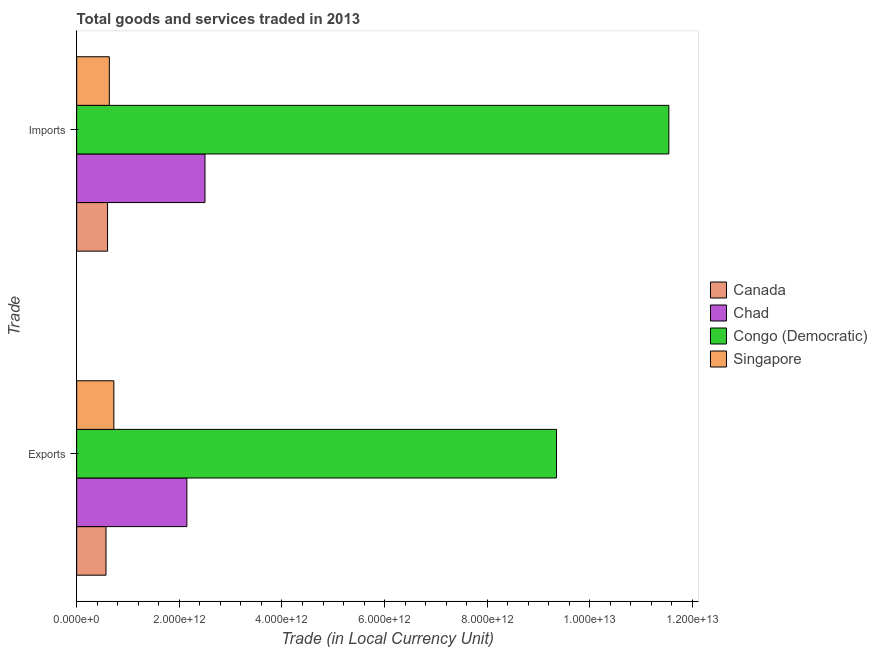How many groups of bars are there?
Offer a very short reply. 2. How many bars are there on the 2nd tick from the top?
Provide a succinct answer. 4. What is the label of the 1st group of bars from the top?
Provide a succinct answer. Imports. What is the export of goods and services in Singapore?
Offer a very short reply. 7.24e+11. Across all countries, what is the maximum imports of goods and services?
Give a very brief answer. 1.15e+13. Across all countries, what is the minimum export of goods and services?
Your answer should be compact. 5.72e+11. In which country was the imports of goods and services maximum?
Your response must be concise. Congo (Democratic). In which country was the export of goods and services minimum?
Provide a succinct answer. Canada. What is the total export of goods and services in the graph?
Give a very brief answer. 1.28e+13. What is the difference between the imports of goods and services in Canada and that in Chad?
Provide a short and direct response. -1.90e+12. What is the difference between the imports of goods and services in Singapore and the export of goods and services in Congo (Democratic)?
Offer a very short reply. -8.71e+12. What is the average export of goods and services per country?
Keep it short and to the point. 3.20e+12. What is the difference between the export of goods and services and imports of goods and services in Singapore?
Provide a succinct answer. 8.78e+1. In how many countries, is the imports of goods and services greater than 8000000000000 LCU?
Offer a terse response. 1. What is the ratio of the imports of goods and services in Singapore to that in Congo (Democratic)?
Provide a short and direct response. 0.06. Is the export of goods and services in Canada less than that in Singapore?
Provide a succinct answer. Yes. What does the 3rd bar from the top in Exports represents?
Offer a terse response. Chad. What does the 2nd bar from the bottom in Exports represents?
Your response must be concise. Chad. Are all the bars in the graph horizontal?
Give a very brief answer. Yes. What is the difference between two consecutive major ticks on the X-axis?
Offer a very short reply. 2.00e+12. Are the values on the major ticks of X-axis written in scientific E-notation?
Ensure brevity in your answer.  Yes. Does the graph contain any zero values?
Make the answer very short. No. Does the graph contain grids?
Offer a very short reply. No. How many legend labels are there?
Make the answer very short. 4. What is the title of the graph?
Make the answer very short. Total goods and services traded in 2013. Does "Middle East & North Africa (all income levels)" appear as one of the legend labels in the graph?
Give a very brief answer. No. What is the label or title of the X-axis?
Make the answer very short. Trade (in Local Currency Unit). What is the label or title of the Y-axis?
Ensure brevity in your answer.  Trade. What is the Trade (in Local Currency Unit) in Canada in Exports?
Provide a short and direct response. 5.72e+11. What is the Trade (in Local Currency Unit) of Chad in Exports?
Provide a succinct answer. 2.15e+12. What is the Trade (in Local Currency Unit) in Congo (Democratic) in Exports?
Provide a succinct answer. 9.35e+12. What is the Trade (in Local Currency Unit) of Singapore in Exports?
Your answer should be very brief. 7.24e+11. What is the Trade (in Local Currency Unit) of Canada in Imports?
Provide a succinct answer. 6.02e+11. What is the Trade (in Local Currency Unit) of Chad in Imports?
Offer a very short reply. 2.50e+12. What is the Trade (in Local Currency Unit) of Congo (Democratic) in Imports?
Your answer should be compact. 1.15e+13. What is the Trade (in Local Currency Unit) in Singapore in Imports?
Offer a very short reply. 6.37e+11. Across all Trade, what is the maximum Trade (in Local Currency Unit) in Canada?
Keep it short and to the point. 6.02e+11. Across all Trade, what is the maximum Trade (in Local Currency Unit) of Chad?
Your answer should be compact. 2.50e+12. Across all Trade, what is the maximum Trade (in Local Currency Unit) of Congo (Democratic)?
Ensure brevity in your answer.  1.15e+13. Across all Trade, what is the maximum Trade (in Local Currency Unit) in Singapore?
Your answer should be compact. 7.24e+11. Across all Trade, what is the minimum Trade (in Local Currency Unit) of Canada?
Ensure brevity in your answer.  5.72e+11. Across all Trade, what is the minimum Trade (in Local Currency Unit) in Chad?
Your answer should be very brief. 2.15e+12. Across all Trade, what is the minimum Trade (in Local Currency Unit) in Congo (Democratic)?
Offer a very short reply. 9.35e+12. Across all Trade, what is the minimum Trade (in Local Currency Unit) of Singapore?
Offer a terse response. 6.37e+11. What is the total Trade (in Local Currency Unit) of Canada in the graph?
Make the answer very short. 1.17e+12. What is the total Trade (in Local Currency Unit) of Chad in the graph?
Your response must be concise. 4.65e+12. What is the total Trade (in Local Currency Unit) in Congo (Democratic) in the graph?
Offer a terse response. 2.09e+13. What is the total Trade (in Local Currency Unit) in Singapore in the graph?
Make the answer very short. 1.36e+12. What is the difference between the Trade (in Local Currency Unit) of Canada in Exports and that in Imports?
Provide a short and direct response. -3.02e+1. What is the difference between the Trade (in Local Currency Unit) of Chad in Exports and that in Imports?
Ensure brevity in your answer.  -3.53e+11. What is the difference between the Trade (in Local Currency Unit) in Congo (Democratic) in Exports and that in Imports?
Your answer should be very brief. -2.19e+12. What is the difference between the Trade (in Local Currency Unit) in Singapore in Exports and that in Imports?
Keep it short and to the point. 8.78e+1. What is the difference between the Trade (in Local Currency Unit) in Canada in Exports and the Trade (in Local Currency Unit) in Chad in Imports?
Your answer should be compact. -1.93e+12. What is the difference between the Trade (in Local Currency Unit) of Canada in Exports and the Trade (in Local Currency Unit) of Congo (Democratic) in Imports?
Ensure brevity in your answer.  -1.10e+13. What is the difference between the Trade (in Local Currency Unit) of Canada in Exports and the Trade (in Local Currency Unit) of Singapore in Imports?
Provide a succinct answer. -6.48e+1. What is the difference between the Trade (in Local Currency Unit) of Chad in Exports and the Trade (in Local Currency Unit) of Congo (Democratic) in Imports?
Ensure brevity in your answer.  -9.39e+12. What is the difference between the Trade (in Local Currency Unit) of Chad in Exports and the Trade (in Local Currency Unit) of Singapore in Imports?
Ensure brevity in your answer.  1.51e+12. What is the difference between the Trade (in Local Currency Unit) of Congo (Democratic) in Exports and the Trade (in Local Currency Unit) of Singapore in Imports?
Offer a very short reply. 8.71e+12. What is the average Trade (in Local Currency Unit) in Canada per Trade?
Give a very brief answer. 5.87e+11. What is the average Trade (in Local Currency Unit) of Chad per Trade?
Ensure brevity in your answer.  2.32e+12. What is the average Trade (in Local Currency Unit) in Congo (Democratic) per Trade?
Offer a terse response. 1.04e+13. What is the average Trade (in Local Currency Unit) in Singapore per Trade?
Give a very brief answer. 6.81e+11. What is the difference between the Trade (in Local Currency Unit) of Canada and Trade (in Local Currency Unit) of Chad in Exports?
Your answer should be very brief. -1.58e+12. What is the difference between the Trade (in Local Currency Unit) in Canada and Trade (in Local Currency Unit) in Congo (Democratic) in Exports?
Your response must be concise. -8.78e+12. What is the difference between the Trade (in Local Currency Unit) in Canada and Trade (in Local Currency Unit) in Singapore in Exports?
Offer a terse response. -1.53e+11. What is the difference between the Trade (in Local Currency Unit) of Chad and Trade (in Local Currency Unit) of Congo (Democratic) in Exports?
Offer a very short reply. -7.20e+12. What is the difference between the Trade (in Local Currency Unit) of Chad and Trade (in Local Currency Unit) of Singapore in Exports?
Offer a terse response. 1.42e+12. What is the difference between the Trade (in Local Currency Unit) in Congo (Democratic) and Trade (in Local Currency Unit) in Singapore in Exports?
Ensure brevity in your answer.  8.63e+12. What is the difference between the Trade (in Local Currency Unit) in Canada and Trade (in Local Currency Unit) in Chad in Imports?
Your response must be concise. -1.90e+12. What is the difference between the Trade (in Local Currency Unit) in Canada and Trade (in Local Currency Unit) in Congo (Democratic) in Imports?
Give a very brief answer. -1.09e+13. What is the difference between the Trade (in Local Currency Unit) of Canada and Trade (in Local Currency Unit) of Singapore in Imports?
Provide a succinct answer. -3.46e+1. What is the difference between the Trade (in Local Currency Unit) of Chad and Trade (in Local Currency Unit) of Congo (Democratic) in Imports?
Provide a short and direct response. -9.04e+12. What is the difference between the Trade (in Local Currency Unit) in Chad and Trade (in Local Currency Unit) in Singapore in Imports?
Offer a very short reply. 1.86e+12. What is the difference between the Trade (in Local Currency Unit) of Congo (Democratic) and Trade (in Local Currency Unit) of Singapore in Imports?
Offer a terse response. 1.09e+13. What is the ratio of the Trade (in Local Currency Unit) in Canada in Exports to that in Imports?
Your response must be concise. 0.95. What is the ratio of the Trade (in Local Currency Unit) of Chad in Exports to that in Imports?
Provide a succinct answer. 0.86. What is the ratio of the Trade (in Local Currency Unit) of Congo (Democratic) in Exports to that in Imports?
Provide a succinct answer. 0.81. What is the ratio of the Trade (in Local Currency Unit) in Singapore in Exports to that in Imports?
Your answer should be very brief. 1.14. What is the difference between the highest and the second highest Trade (in Local Currency Unit) of Canada?
Offer a very short reply. 3.02e+1. What is the difference between the highest and the second highest Trade (in Local Currency Unit) in Chad?
Provide a short and direct response. 3.53e+11. What is the difference between the highest and the second highest Trade (in Local Currency Unit) in Congo (Democratic)?
Your answer should be very brief. 2.19e+12. What is the difference between the highest and the second highest Trade (in Local Currency Unit) of Singapore?
Offer a terse response. 8.78e+1. What is the difference between the highest and the lowest Trade (in Local Currency Unit) of Canada?
Offer a very short reply. 3.02e+1. What is the difference between the highest and the lowest Trade (in Local Currency Unit) of Chad?
Offer a terse response. 3.53e+11. What is the difference between the highest and the lowest Trade (in Local Currency Unit) in Congo (Democratic)?
Your answer should be very brief. 2.19e+12. What is the difference between the highest and the lowest Trade (in Local Currency Unit) of Singapore?
Your answer should be very brief. 8.78e+1. 